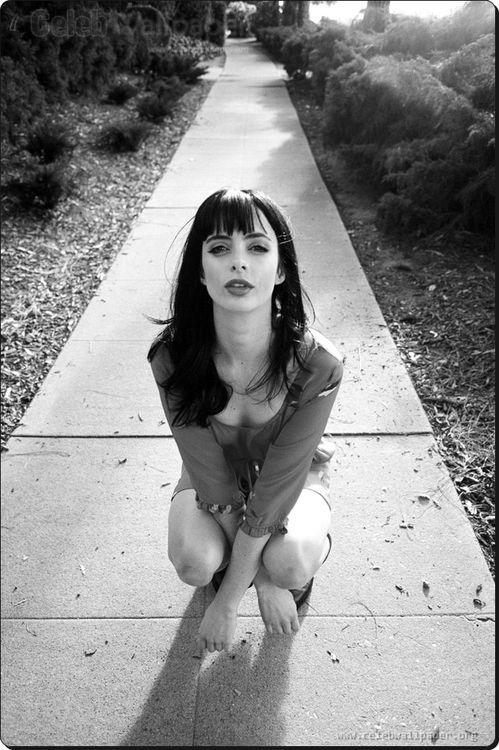What might be the emotional tone or mood conveyed by this portrait? The emotional tone of this portrait seems to convey a deep introspection or solemnity. The woman's serious facial expression and direct gaze into the camera suggest a moment of candidness or a pause in action, perhaps reflecting on personal thoughts or emotions. The outdoor setting, combined with her poised yet relaxed posture, adds an element of calmness and stillness to the mood. 